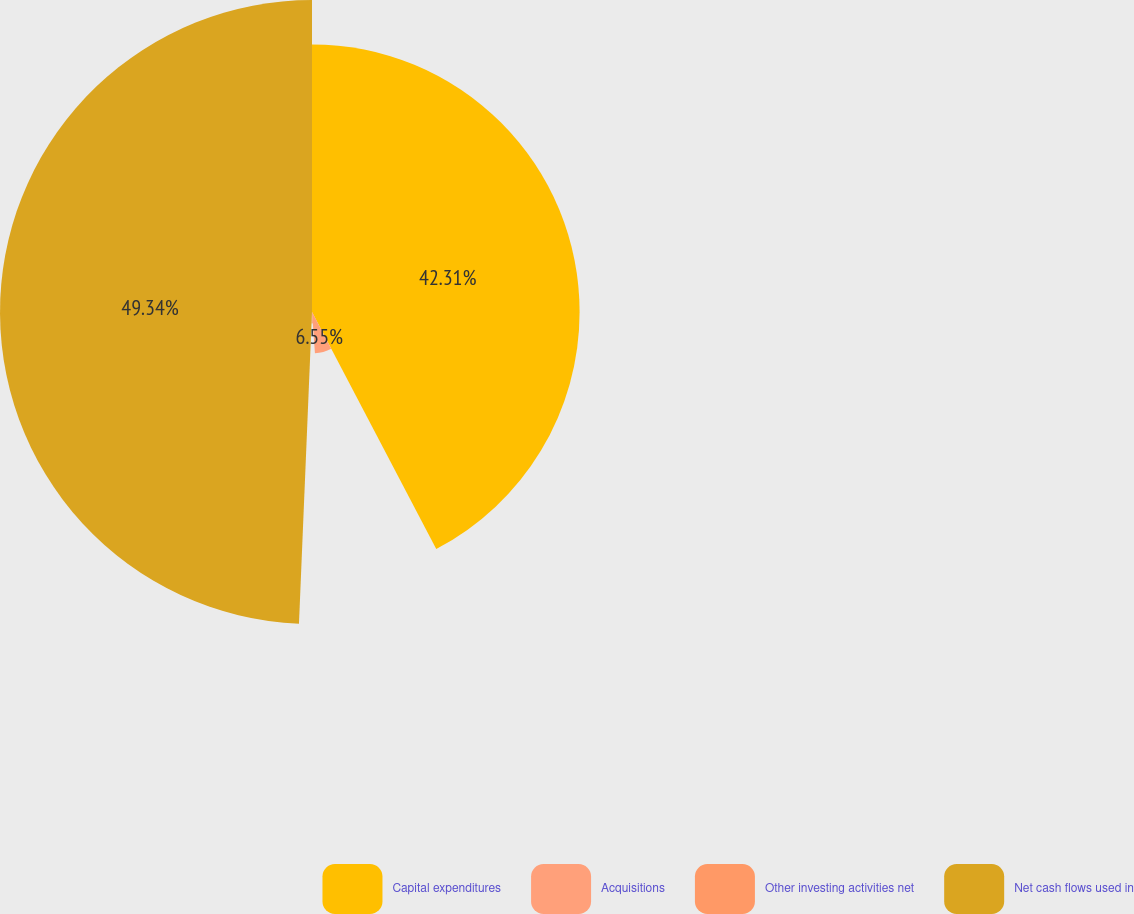Convert chart. <chart><loc_0><loc_0><loc_500><loc_500><pie_chart><fcel>Capital expenditures<fcel>Acquisitions<fcel>Other investing activities net<fcel>Net cash flows used in<nl><fcel>42.31%<fcel>6.55%<fcel>1.8%<fcel>49.33%<nl></chart> 